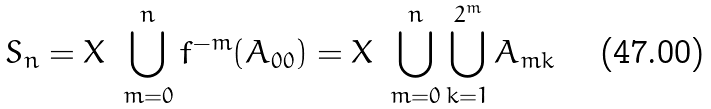<formula> <loc_0><loc_0><loc_500><loc_500>S _ { n } = X \ \bigcup _ { m = 0 } ^ { n } f ^ { - m } ( A _ { 0 0 } ) = X \ \bigcup _ { m = 0 } ^ { n } \bigcup _ { k = 1 } ^ { 2 ^ { m } } A _ { m k }</formula> 